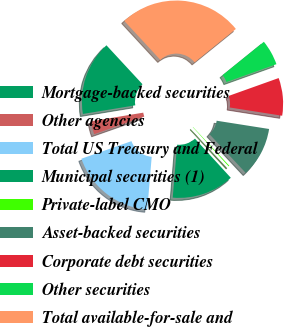Convert chart. <chart><loc_0><loc_0><loc_500><loc_500><pie_chart><fcel>Mortgage-backed securities<fcel>Other agencies<fcel>Total US Treasury and Federal<fcel>Municipal securities (1)<fcel>Private-label CMO<fcel>Asset-backed securities<fcel>Corporate debt securities<fcel>Other securities<fcel>Total available-for-sale and<nl><fcel>15.72%<fcel>2.77%<fcel>18.31%<fcel>13.13%<fcel>0.18%<fcel>10.54%<fcel>7.95%<fcel>5.36%<fcel>26.08%<nl></chart> 